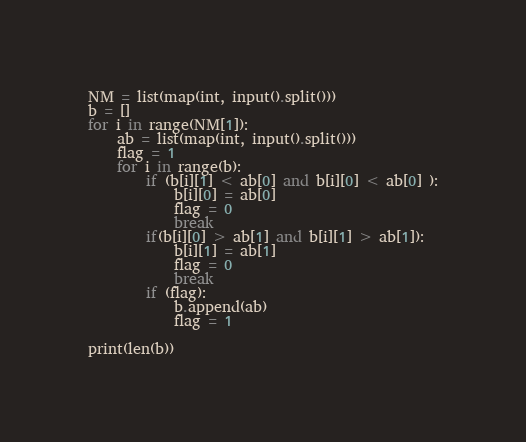<code> <loc_0><loc_0><loc_500><loc_500><_Python_>NM = list(map(int, input().split()))
b = []
for i in range(NM[1]):
	ab = list(map(int, input().split()))
	flag = 1
	for i in range(b):
		if (b[i][1] < ab[0] and b[i][0] < ab[0] ):
			b[i][0] = ab[0]
			flag = 0
			break
		if(b[i][0] > ab[1] and b[i][1] > ab[1]):
			b[i][1] = ab[1] 
			flag = 0
			break
		if (flag):
			b.append(ab)
			flag = 1

print(len(b))</code> 